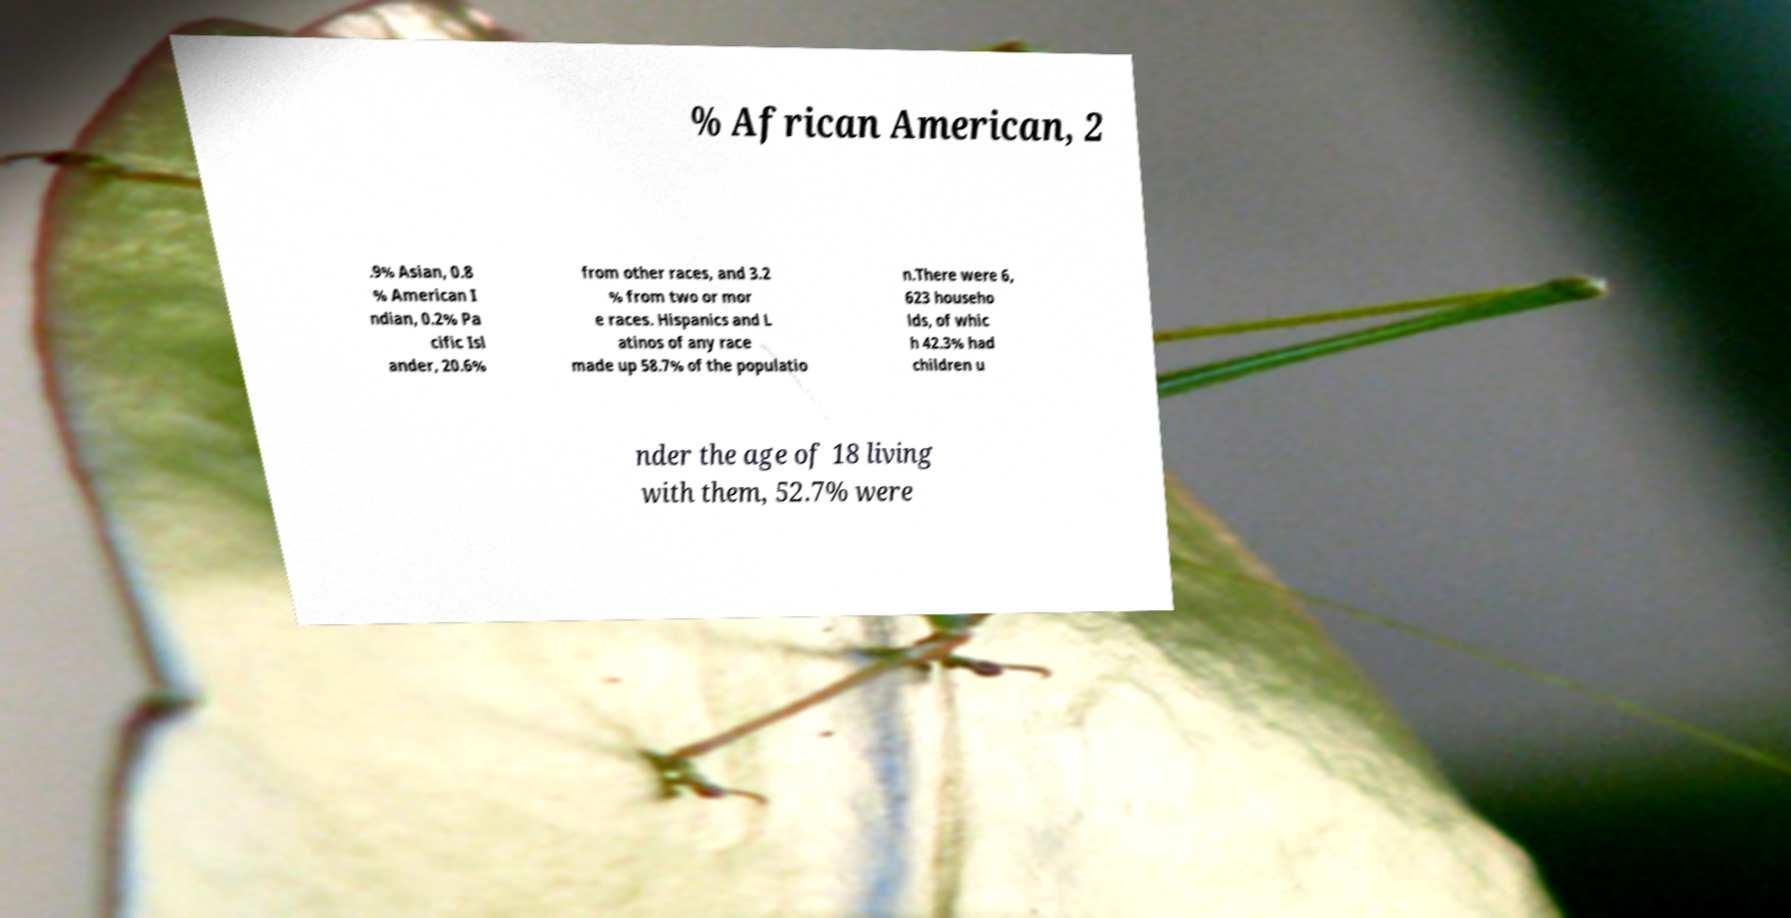Please read and relay the text visible in this image. What does it say? % African American, 2 .9% Asian, 0.8 % American I ndian, 0.2% Pa cific Isl ander, 20.6% from other races, and 3.2 % from two or mor e races. Hispanics and L atinos of any race made up 58.7% of the populatio n.There were 6, 623 househo lds, of whic h 42.3% had children u nder the age of 18 living with them, 52.7% were 